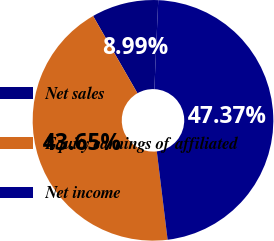Convert chart. <chart><loc_0><loc_0><loc_500><loc_500><pie_chart><fcel>Net sales<fcel>Equity earnings of affiliated<fcel>Net income<nl><fcel>8.99%<fcel>43.65%<fcel>47.37%<nl></chart> 